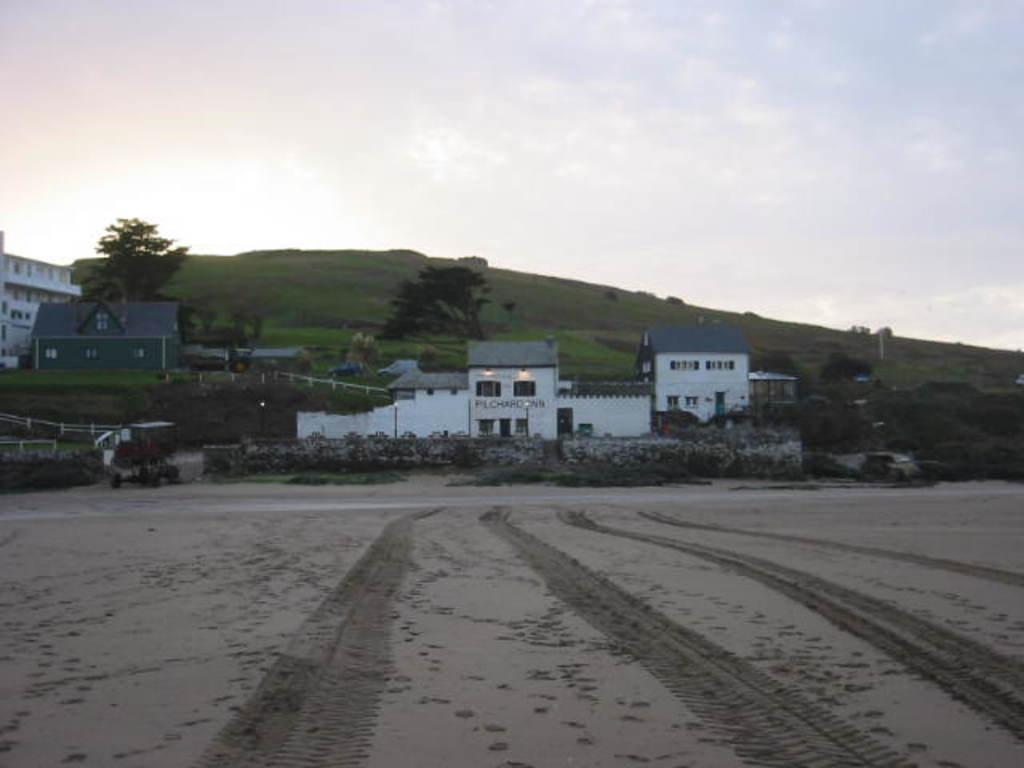How would you summarize this image in a sentence or two? In this image I can see buildings and trees and the hill, at the top I can see the sky. 